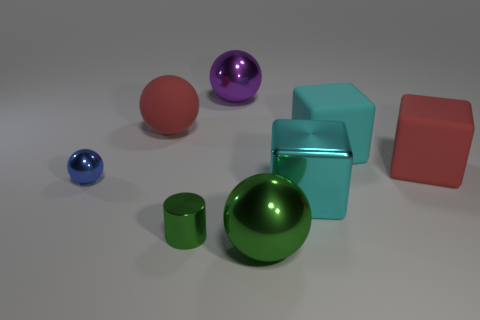Add 1 big red matte spheres. How many objects exist? 9 Subtract all blocks. How many objects are left? 5 Add 2 big green metallic balls. How many big green metallic balls exist? 3 Subtract 1 red balls. How many objects are left? 7 Subtract all yellow spheres. Subtract all matte things. How many objects are left? 5 Add 3 large shiny things. How many large shiny things are left? 6 